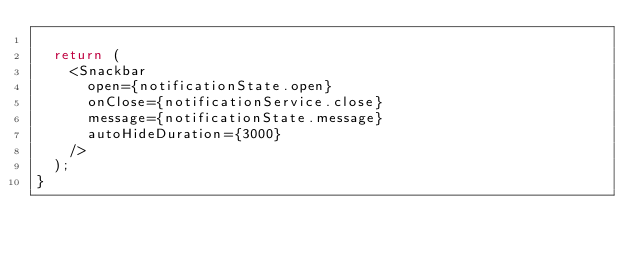<code> <loc_0><loc_0><loc_500><loc_500><_JavaScript_>
  return (
    <Snackbar
      open={notificationState.open}
      onClose={notificationService.close}
      message={notificationState.message}
      autoHideDuration={3000}
    />
  );
}
</code> 